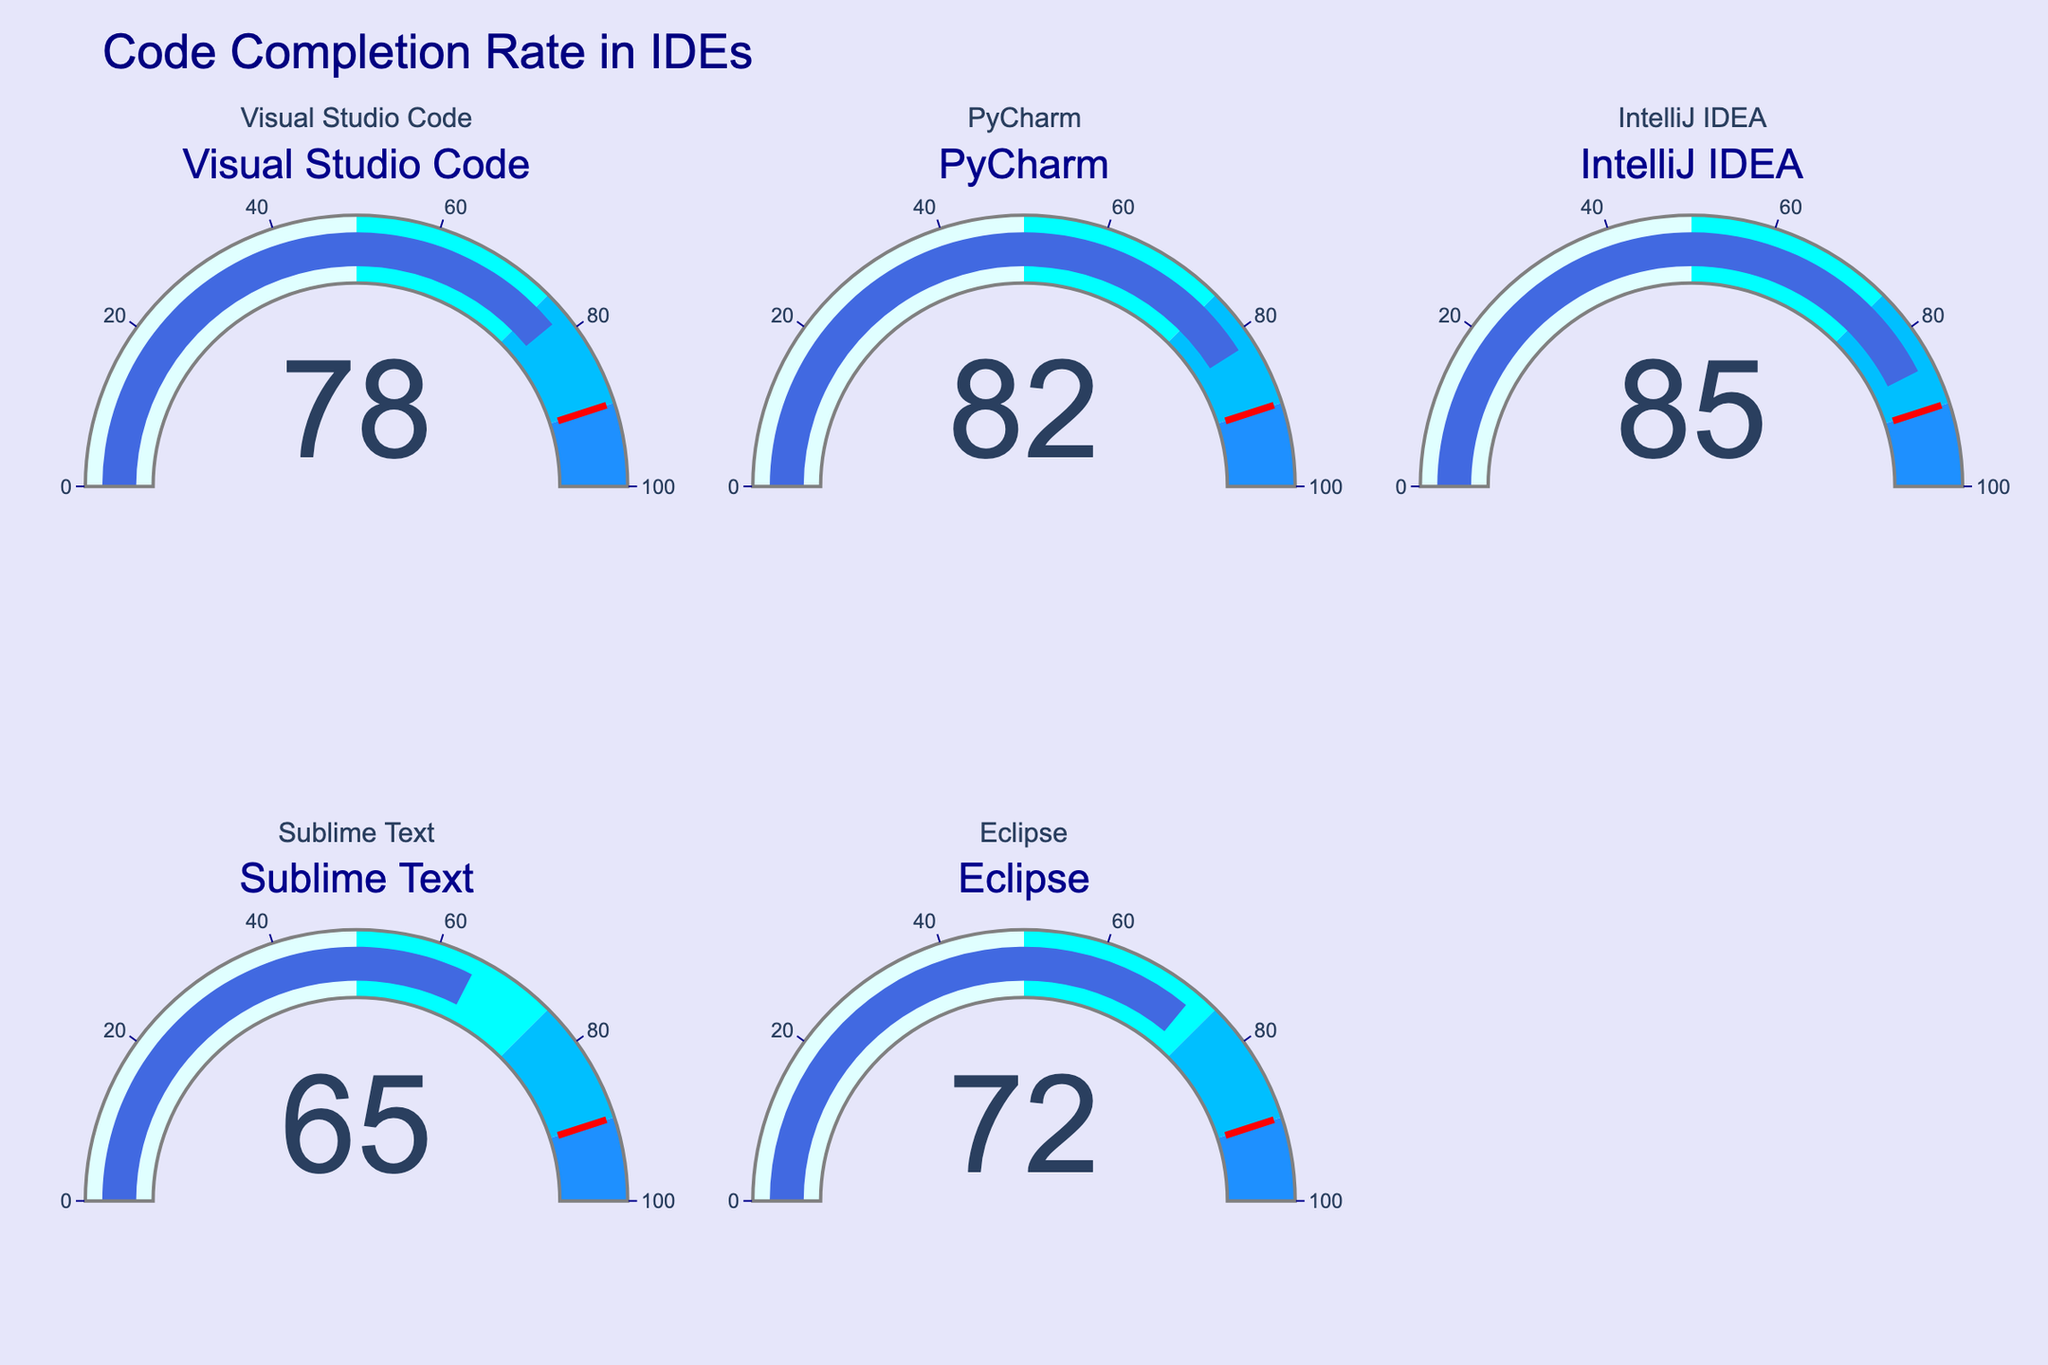What's the title of the figure? The title of the figure is displayed at the top of the chart. It reads "Code Completion Rate in IDEs".
Answer: Code Completion Rate in IDEs How many IDEs are represented in the figure? The figure contains gauges, each representing a different IDE. Counting these gauges, there are five IDEs represented.
Answer: Five Which IDE has the highest code completion rate? By looking at the gauge values, IntelliJ IDEA has the highest code completion rate at 85.
Answer: IntelliJ IDEA Which IDE has the lowest code completion rate? By looking at the gauge values, Sublime Text has the lowest completion rate at 65.
Answer: Sublime Text What is the average code completion rate of all IDEs? To calculate the average, sum the completion rates (78, 82, 85, 65, 72) which equals 382, then divide by the number of IDEs which is 5. So, 382 / 5 = 76.4.
Answer: 76.4 What is the gap between the highest and the lowest code completion rates? To find the gap, subtract the lowest completion rate (65) from the highest (85). So, 85 - 65 = 20.
Answer: 20 Which IDEs have a code completion rate greater than 75? By looking at the gauge values, three IDEs have a code completion rate greater than 75: Visual Studio Code (78), PyCharm (82), and IntelliJ IDEA (85).
Answer: Visual Studio Code, PyCharm, IntelliJ IDEA What is the median code completion rate of the IDEs? To find the median, list the completion rates in ascending order (65, 72, 78, 82, 85) and find the middle value. The median is the third value which is 78.
Answer: 78 Which IDEs fall into the 'deepskyblue' gauge color range (75-90)? The 'deepskyblue' color range on the gauge indicates rates between 75 and 90. The IDEs in this range are Visual Studio Code (78), PyCharm (82), and IntelliJ IDEA (85).
Answer: Visual Studio Code, PyCharm, IntelliJ IDEA Do any IDEs fall above the threshold of 90? The threshold marked by a red line on the gauges is set at 90. None of the IDEs have a code completion rate above this threshold.
Answer: No 